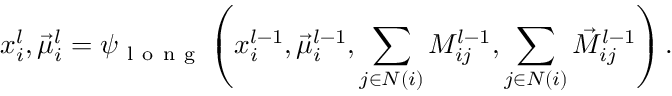<formula> <loc_0><loc_0><loc_500><loc_500>x _ { i } ^ { l } , \vec { \mu } _ { i } ^ { l } = \psi _ { l o n g } \left ( x _ { i } ^ { l - 1 } , \vec { \mu } _ { i } ^ { l - 1 } , \sum _ { j \in N ( i ) } M _ { i j } ^ { l - 1 } , \sum _ { j \in N ( i ) } \vec { M } _ { i j } ^ { l - 1 } \right ) .</formula> 